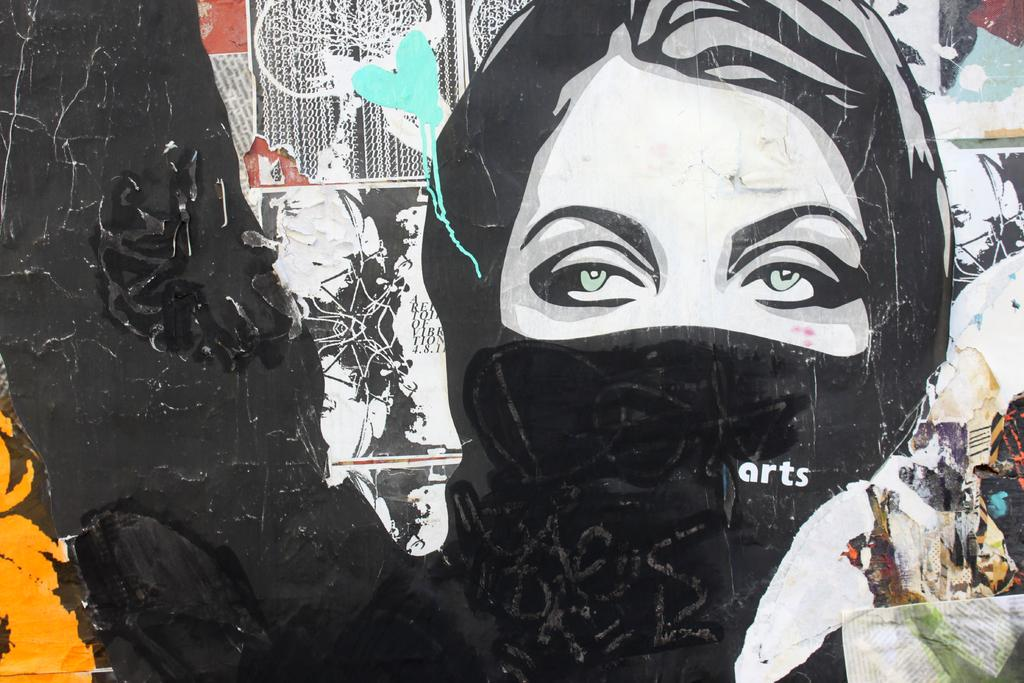What is depicted on the wall in the image? There is a wall painting in the image, which features a lady wearing a mask. Are there any other items or features on the wall in the image? Yes, there are papers pasted on the wall in the image. How many nerves are visible in the image? There are no nerves visible in the image; it features a wall painting and papers pasted on the wall. 